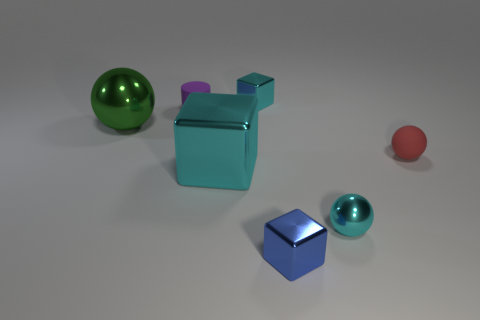How would you describe the lighting in this scene? The lighting is soft and diffused, creating gentle shadows and highlights on the objects and giving the scene a calm and balanced atmosphere. 